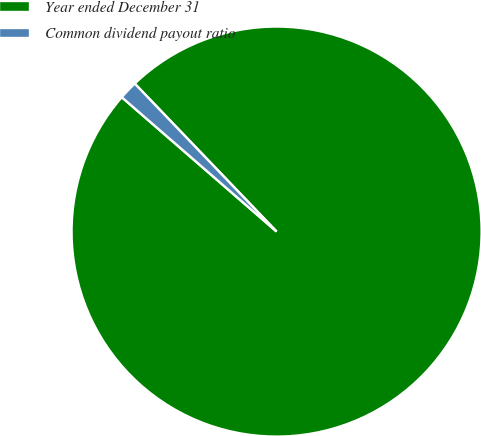Convert chart to OTSL. <chart><loc_0><loc_0><loc_500><loc_500><pie_chart><fcel>Year ended December 31<fcel>Common dividend payout ratio<nl><fcel>98.54%<fcel>1.46%<nl></chart> 